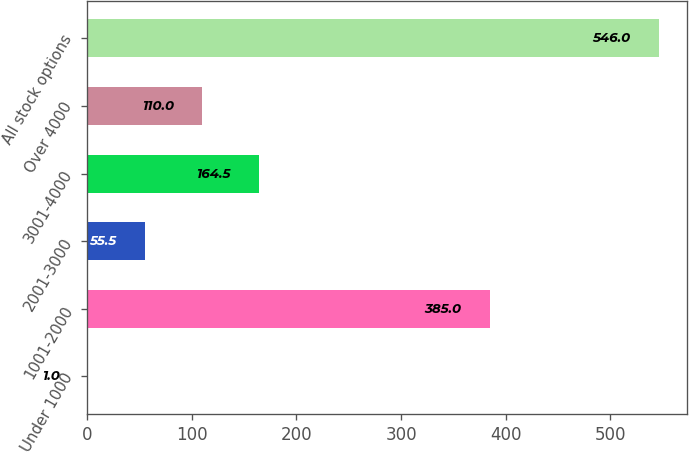Convert chart to OTSL. <chart><loc_0><loc_0><loc_500><loc_500><bar_chart><fcel>Under 1000<fcel>1001-2000<fcel>2001-3000<fcel>3001-4000<fcel>Over 4000<fcel>All stock options<nl><fcel>1<fcel>385<fcel>55.5<fcel>164.5<fcel>110<fcel>546<nl></chart> 